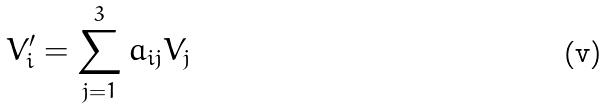<formula> <loc_0><loc_0><loc_500><loc_500>V _ { i } ^ { \prime } = \sum _ { j = 1 } ^ { 3 } a _ { i j } V _ { j }</formula> 